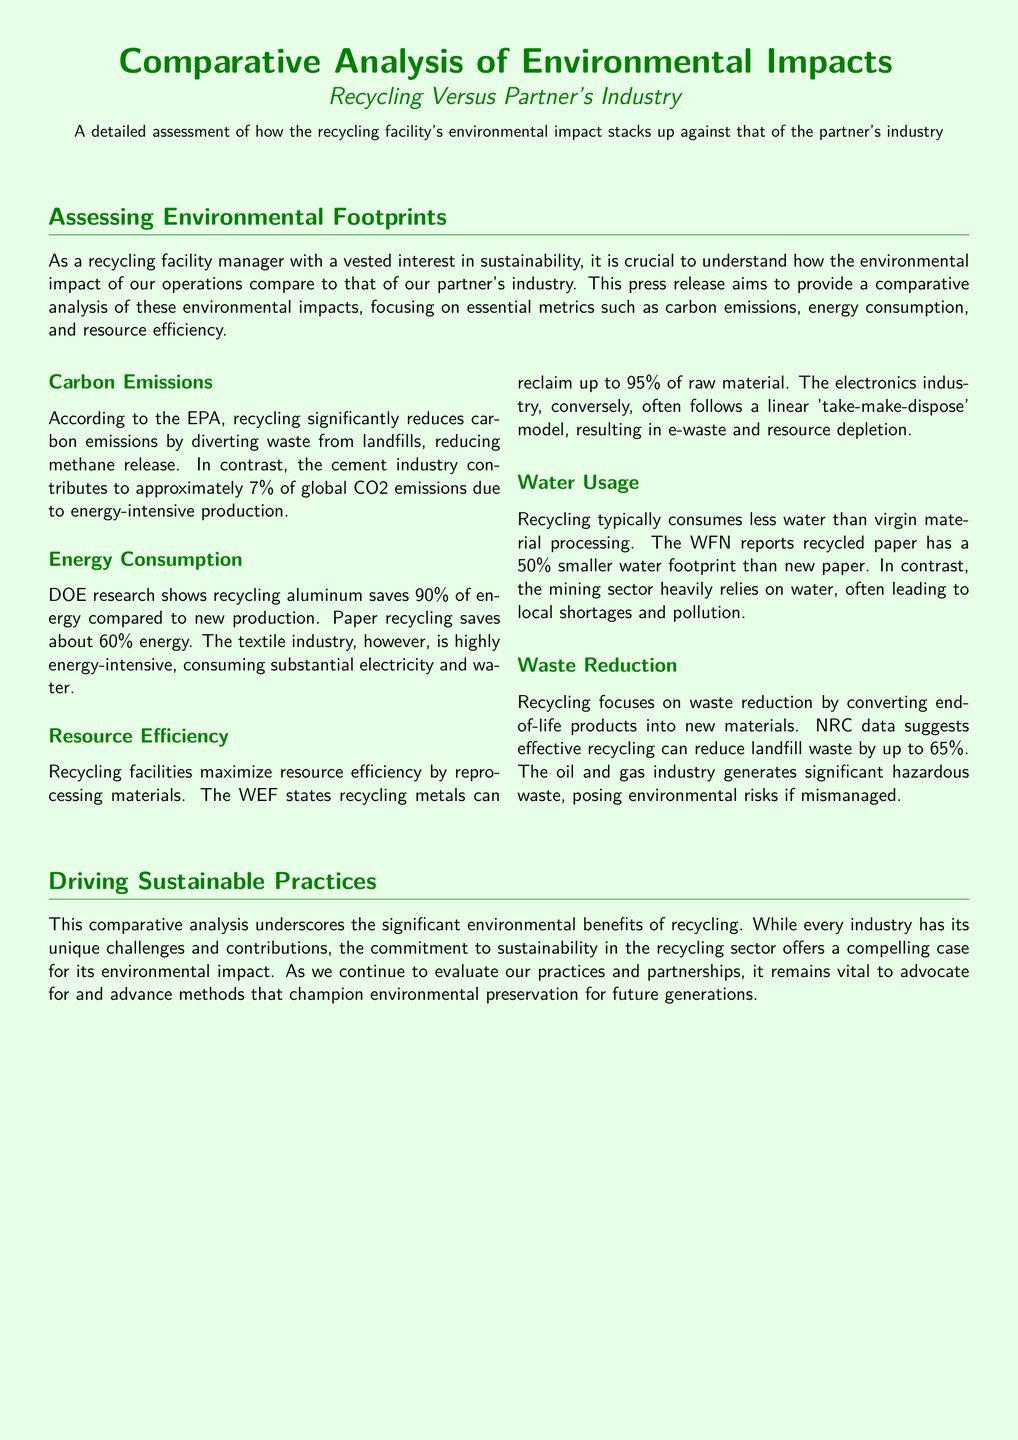What percentage of energy does recycling aluminum save compared to new production? The document states that recycling aluminum saves 90% of energy compared to new production.
Answer: 90% What industry contributes to approximately 7% of global CO2 emissions? The press release mentions that the cement industry contributes to approximately 7% of global CO2 emissions.
Answer: Cement industry How much water does recycled paper have a smaller footprint than new paper? The WFN reports that recycled paper has a 50% smaller water footprint than new paper.
Answer: 50% What is the percentage of landfill waste that effective recycling can reduce? The NRC data suggests effective recycling can reduce landfill waste by up to 65%.
Answer: 65% Which industry's model results in e-waste and resource depletion? The document indicates that the electronics industry follows a linear 'take-make-dispose' model, resulting in e-waste and resource depletion.
Answer: Electronics industry What does DOE research show about the energy savings of paper recycling? The document states that paper recycling saves about 60% energy.
Answer: 60% What does the comparative analysis highlight about the recycling sector? The press release emphasizes the significant environmental benefits of recycling that the recycling sector offers a compelling case for its environmental impact.
Answer: Significant environmental benefits How does recycling typically compare to virgin material processing in water usage? The press release mentions that recycling typically consumes less water than virgin material processing.
Answer: Less water What is the primary focus of recycling according to the document? The document states that recycling focuses on waste reduction by converting end-of-life products into new materials.
Answer: Waste reduction 